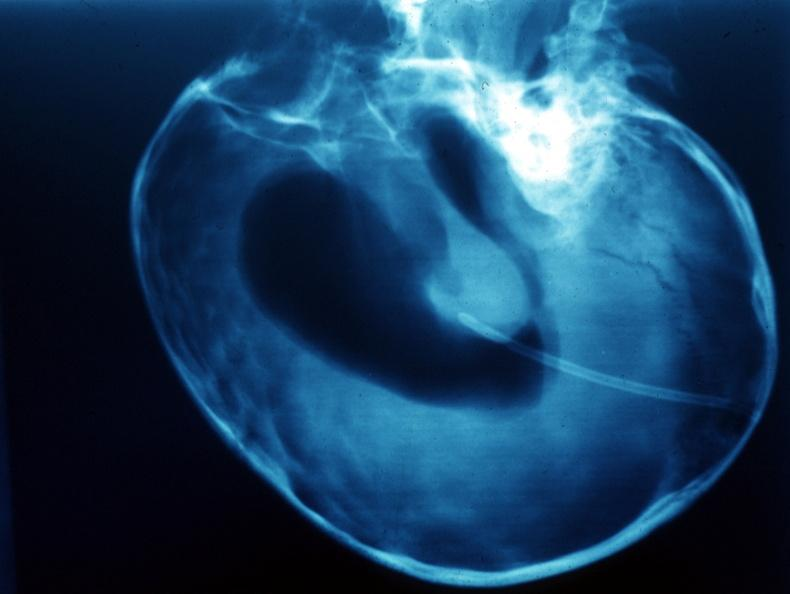does this image show x-ray air contrast showing enlarged lateral ventricles?
Answer the question using a single word or phrase. Yes 